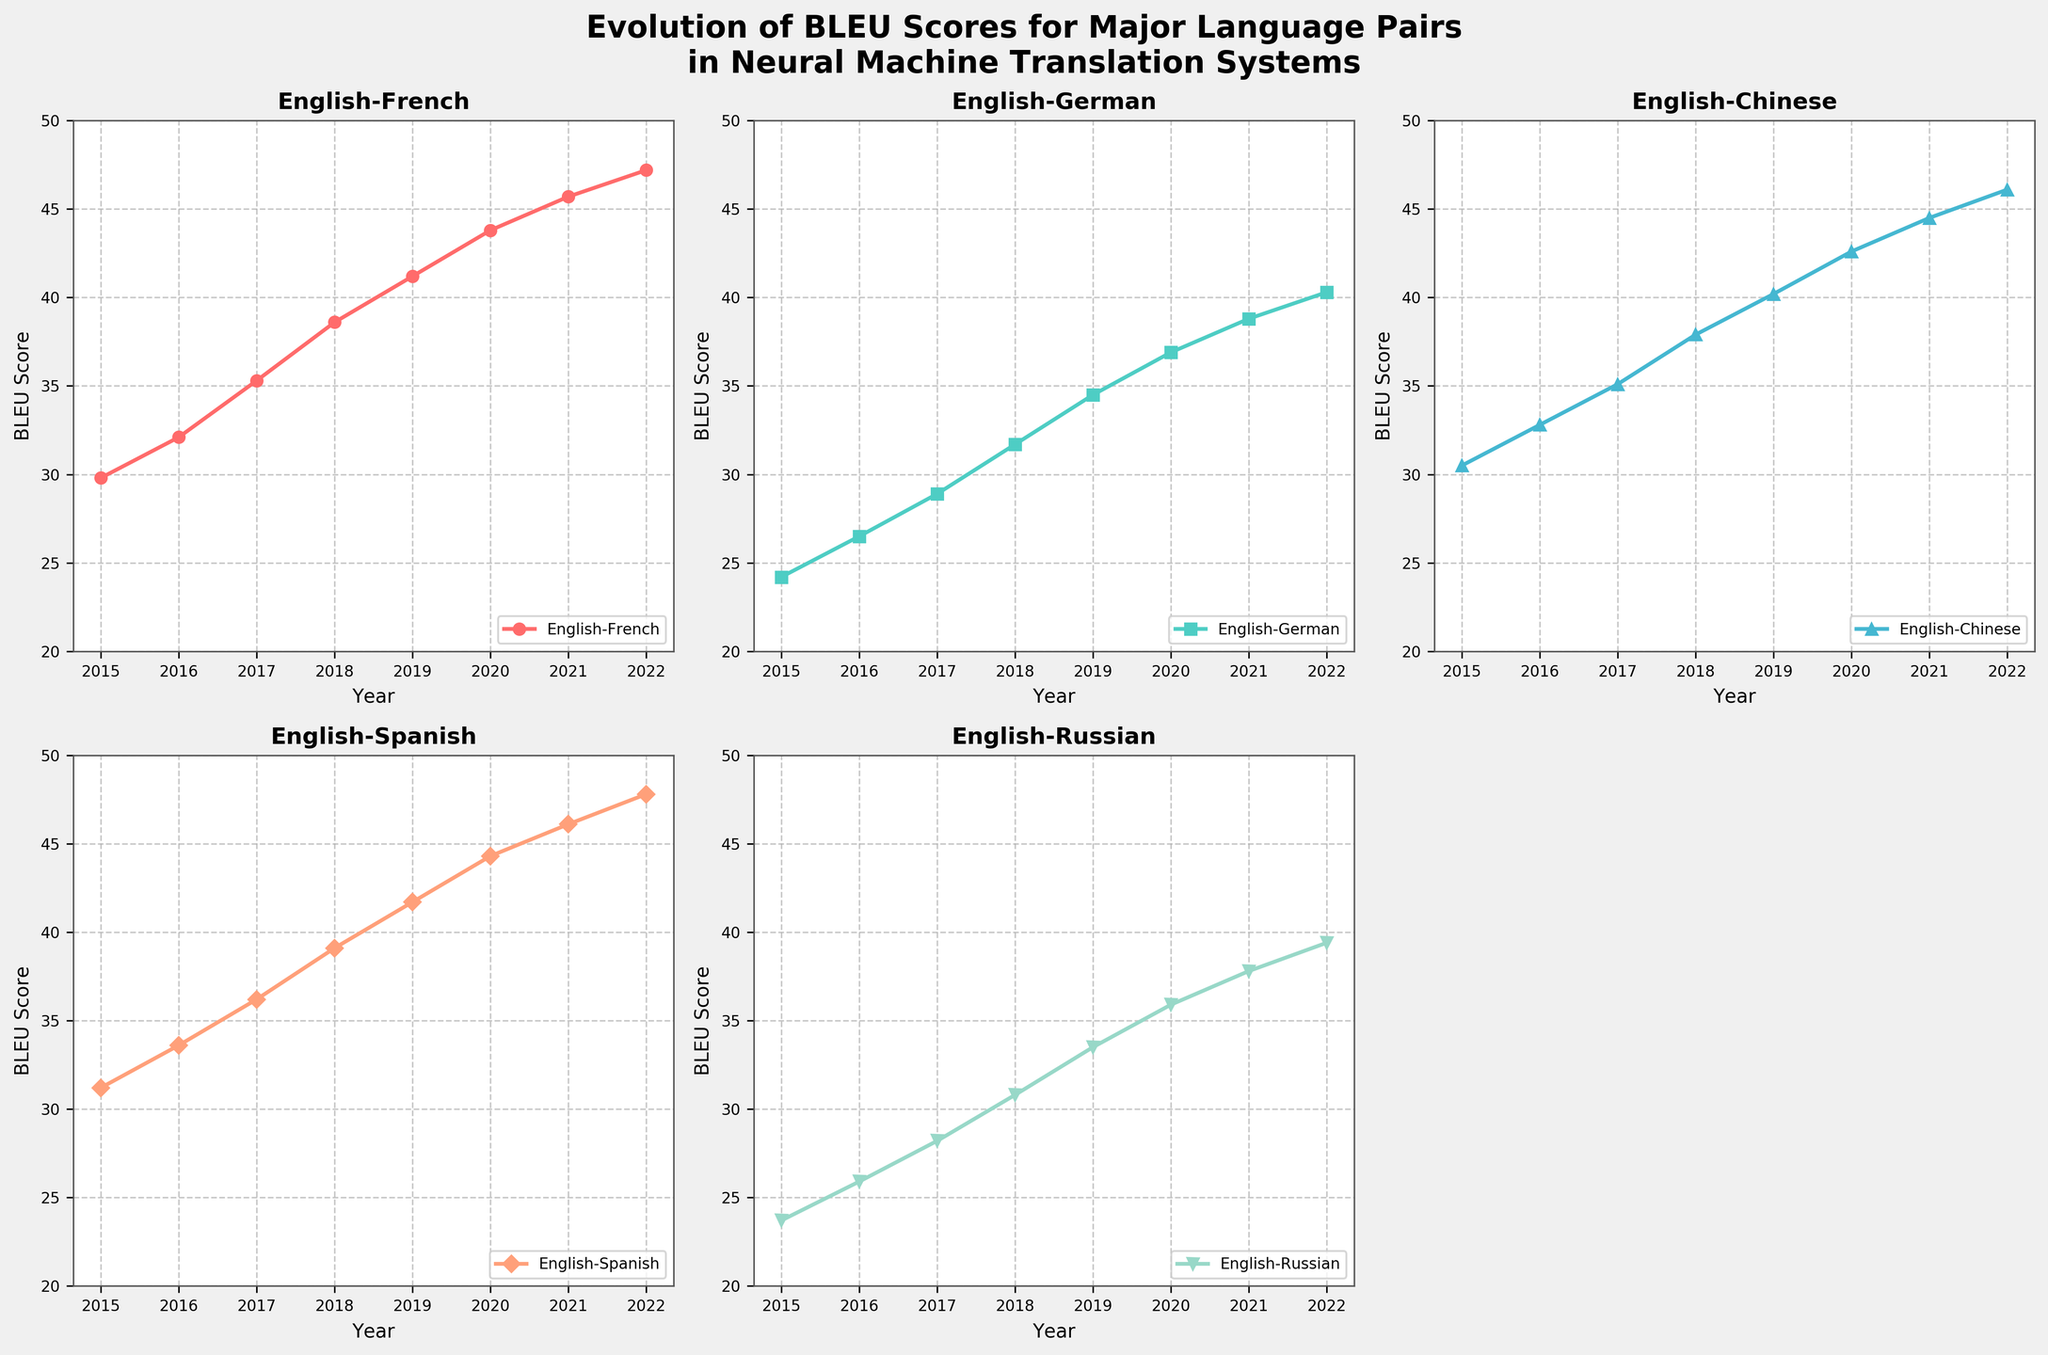What is the title of the figure? The title of the figure is usually found at the top of the plot area and provides an overview of what the figure is about.
Answer: Evolution of BLEU Scores for Major Language Pairs in Neural Machine Translation Systems Which language pair consistently has the highest BLEU score over the years? To determine which language pair consistently has the highest BLEU score, observe the lines representing each language pair and compare their positions year by year. The highest position indicates the highest BLEU score.
Answer: English-Spanish In which year did the English-German BLEU score first surpass 30.0? To find this, look at the plot for the English-German BLEU scores and identify the year when the value crossed the 30.0 mark.
Answer: 2018 By how much did the BLEU score for English-Russian increase from 2015 to 2022? To calculate this, subtract the BLEU score for English-Russian in 2015 from the BLEU score in 2022.
Answer: 15.7 What is the overall trend observed for all language pairs in terms of BLEU scores from 2015 to 2022? To understand the trend, observe the direction of the lines for each language pair. A rising line indicates an increasing trend.
Answer: Increasing Which language pair had the smallest improvement in BLEU score from 2015 to 2016? To find this, compute the difference in BLEU scores for each language pair between 2015 and 2016 and identify the smallest value.
Answer: English-Russian Compare the BLEU score trends for English-Chinese and English-French. Which one shows a steeper increase? To compare the trends, observe the slopes of the lines representing English-Chinese and English-French BLEU scores. A steeper slope indicates a greater rate of increase.
Answer: English-Chinese Between the years 2017 and 2018, which language pair showed the greatest increase in BLEU score, and by how much? Look at the difference in BLEU scores for each language pair between 2017 and 2018, and identify the one with the greatest increase.
Answer: English-Chinese, 2.8 What is the BLEU score for English-Spanish in 2020? Find the point on the English-Spanish line that corresponds to the year 2020 and note the BLEU score.
Answer: 44.3 How many subplots are present in the figure, and what is unique about the last subplot? Count the number of individual plots within the figure. Note if there is anything different about the last one.
Answer: 6 subplots, the last one is unused and turned off 